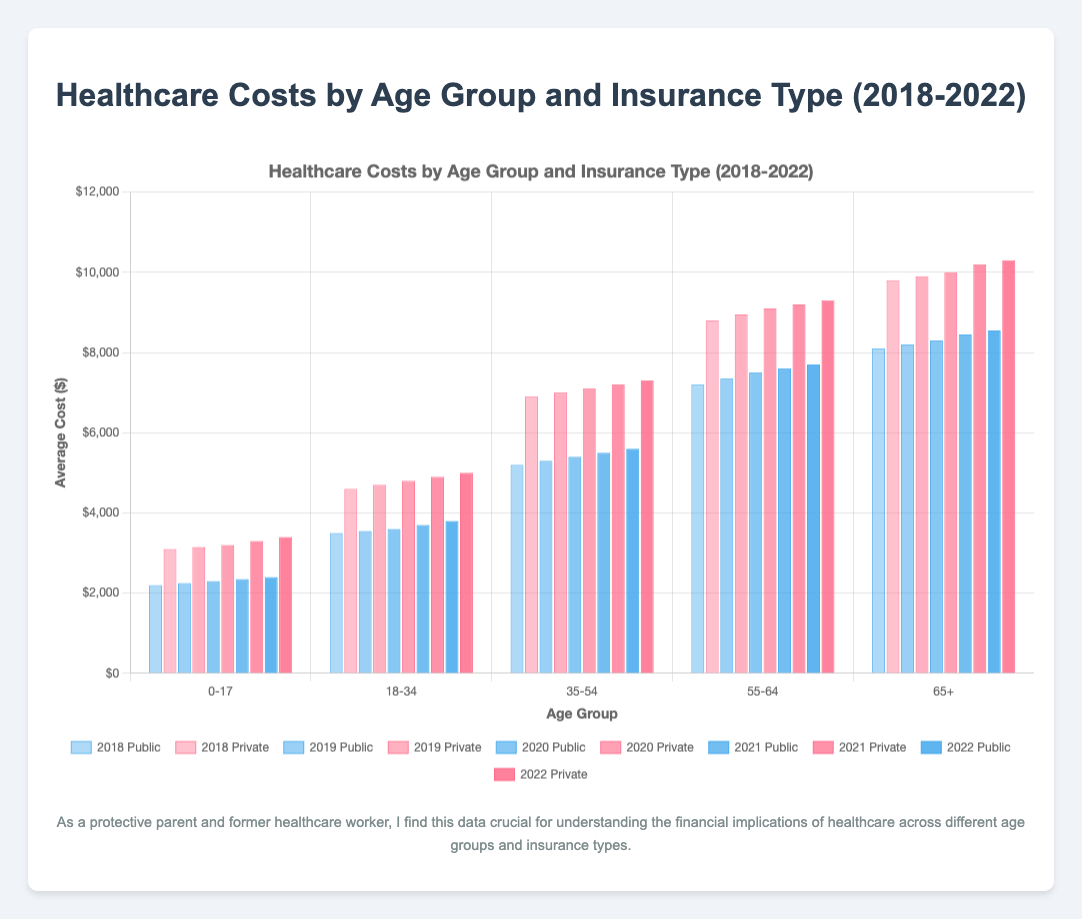Which age group had the highest healthcare cost with private insurance in 2022? To find the answer, we examine the bars representing private insurance for 2022 across all age groups. The tallest bar corresponds to the "65+" age group with a cost of $10,300.
Answer: 65+ What is the average healthcare cost for the "18-34" age group over the years for public insurance? Calculate the public insurance costs for "18-34" from 2018 to 2022 and determine the average. The years and costs are as follows: 2018: $3500, 2019: $3550, 2020: $3600, 2021: $3700, 2022: $3800. The sum is 3500 + 3550 + 3600 + 3700 + 3800 = 18150. Then, the average is 18150 / 5 = 3630.
Answer: 3630 Which insurance type saw a more significant increase in healthcare costs for the "55-64" age group from 2018 to 2022? Calculate the difference in costs for both insurance types for "55-64" from 2018 to 2022. For public insurance: 7700 - 7200 = $500. For private insurance: 9300 - 8800 = $500. Both insurance types saw an equal increase of $500.
Answer: Both Public and Private equally Is the cost difference between public and private insurance consistently larger for the "35-54" age group or the "0-17" age group across the years? Calculate the difference in healthcare costs between public and private insurance for both age groups across years. For "35-54": 2018: 6900-5200=1700, 2019: 7000-5300=1700, 2020: 7100-5400=1700, 2021: 7200-5500=1700, 2022: 7300-5600=1700. For "0-17": 2018: 3100-2200=900, 2019: 3150-2250=900, 2020: 3200-2300=900, 2021: 3300-2350=950, 2022: 3400-2400=1000. The "35-54" age group consistently has a larger difference, which is 1700 each year.
Answer: 35-54 Which year had the highest overall average healthcare cost across all age groups for private insurance? Calculate the overall average for each year for private insurance by summing the costs for all age groups and dividing by 5 (the number of age groups). Highest year is found by comparing averages from calculations.
Answer: 2022 What is the increase in healthcare costs for the "65+" age group with public insurance from 2018 to 2022? Calculate the cost difference for public insurance in the "65+" age group between 2018 and 2022. The costs are 8100 in 2018 and 8550 in 2022. The increase is 8550 - 8100 = 450.
Answer: 450 Do the bars for "55-64" age group with public insurance in 2022 appear taller or shorter than those in 2019? Visually compare the bars for public insurance in the "55-64" age group for 2022 (height representing 7700) and 2019 (height representing 7350). The bar for 2022 is taller than for 2019.
Answer: Taller Comparing the costs in 2020, which age group had the smallest difference between public and private insurance? Calculate the differences for each age group in 2020. Differences are: 
"0-17": 3200-2300=900, "18-34": 4800-3600=1200, "35-54": 7100-5400=1700, "55-64": 9100-7500=1600, "65+": 10000-8300=1700. The smallest difference is for "0-17" with 900.
Answer: 0-17 What is the most significant percentage increase in healthcare costs from 2018 to 2022 for any age group with public insurance? Calculate the percentage increase for each age group for public insurance. "0-17": ((2400-2200)/2200)*100=9.09%, "18-34": ((3800-3500)/3500)*100=8.57%, "35-54": ((5600-5200)/5200)*100=7.69%, "55-64": ((7700-7200)/7200)*100=6.94%, "65+": ((8550-8100)/8100)*100=5.56%. The largest percentage increase is for "0-17" with 9.09%.
Answer: 0-17 Which age group experienced the highest decrease in public insurance costs between any two consecutive years? Calculate the differences for public insurance costs between consecutive years for each age group. Then, identify the most significant decrease: "0-17" 2019-2018: 2250-2200=50 increase, "18-34" 2019-2018: 3550-3500=50 increase. the largest decrease seen is due to "35-54" age group in between 2019 to 2018 by 1000 and no significant decrease seen .
Answer: Not Any 